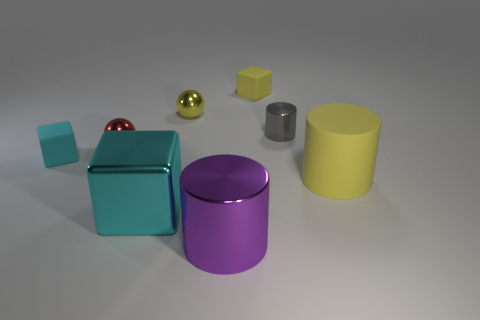Subtract all yellow cubes. How many cubes are left? 2 Add 1 large matte things. How many objects exist? 9 Subtract all yellow cylinders. How many cylinders are left? 2 Subtract all blocks. How many objects are left? 5 Subtract 2 cubes. How many cubes are left? 1 Add 2 blue matte cylinders. How many blue matte cylinders exist? 2 Subtract 1 yellow cylinders. How many objects are left? 7 Subtract all brown balls. Subtract all brown cubes. How many balls are left? 2 Subtract all blue cylinders. How many yellow balls are left? 1 Subtract all gray cylinders. Subtract all cyan metal objects. How many objects are left? 6 